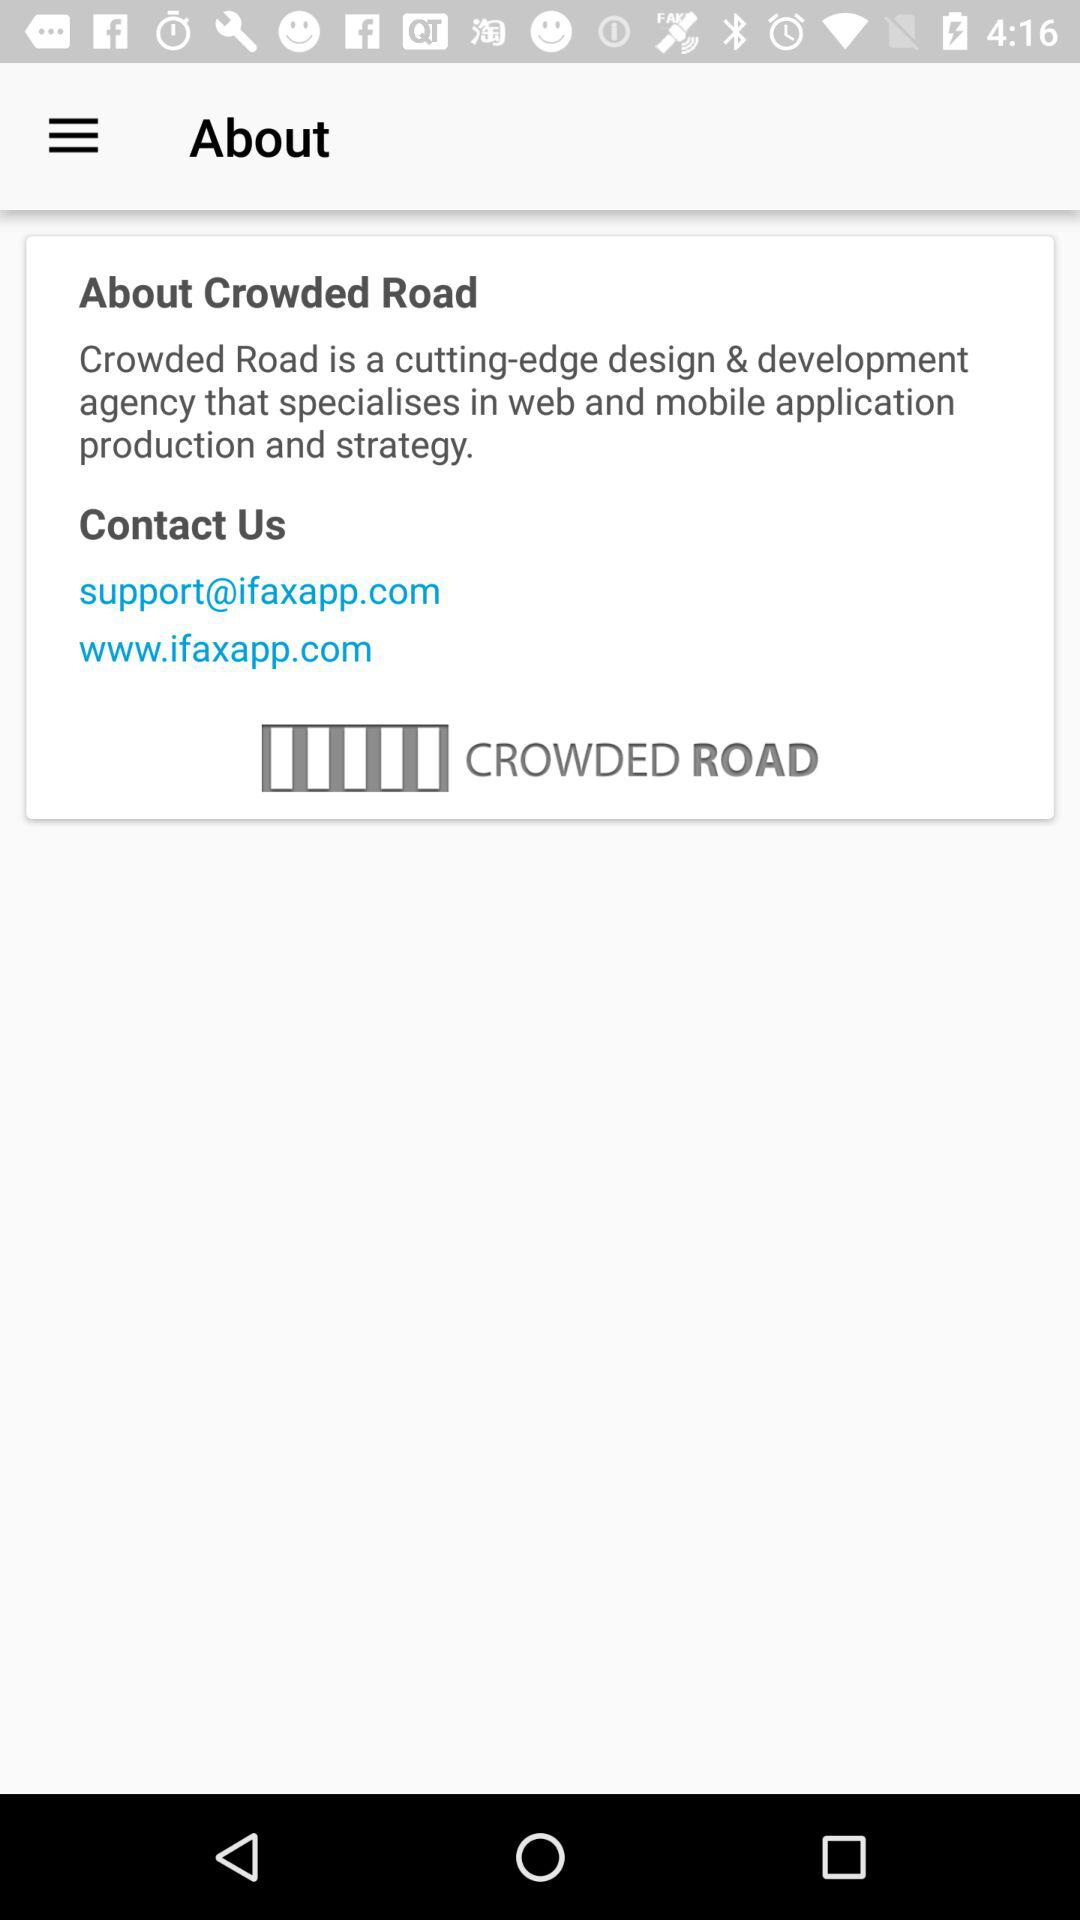Which are the different options to contact? The different options to contact are "support@ifaxapp.com" and "www.ifaxapp.com". 